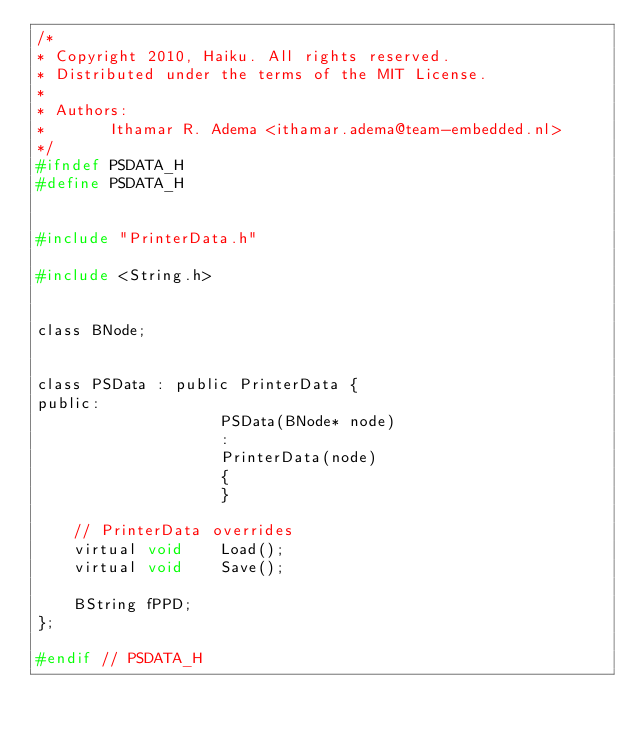<code> <loc_0><loc_0><loc_500><loc_500><_C_>/*
* Copyright 2010, Haiku. All rights reserved.
* Distributed under the terms of the MIT License.
*
* Authors:
*		Ithamar R. Adema <ithamar.adema@team-embedded.nl>
*/
#ifndef PSDATA_H
#define PSDATA_H


#include "PrinterData.h"

#include <String.h>


class BNode;


class PSData : public PrinterData {
public:
					PSData(BNode* node)
					:
					PrinterData(node)
					{
					}

	// PrinterData overrides
	virtual	void	Load();
	virtual	void	Save();

	BString fPPD;
};

#endif // PSDATA_H
</code> 